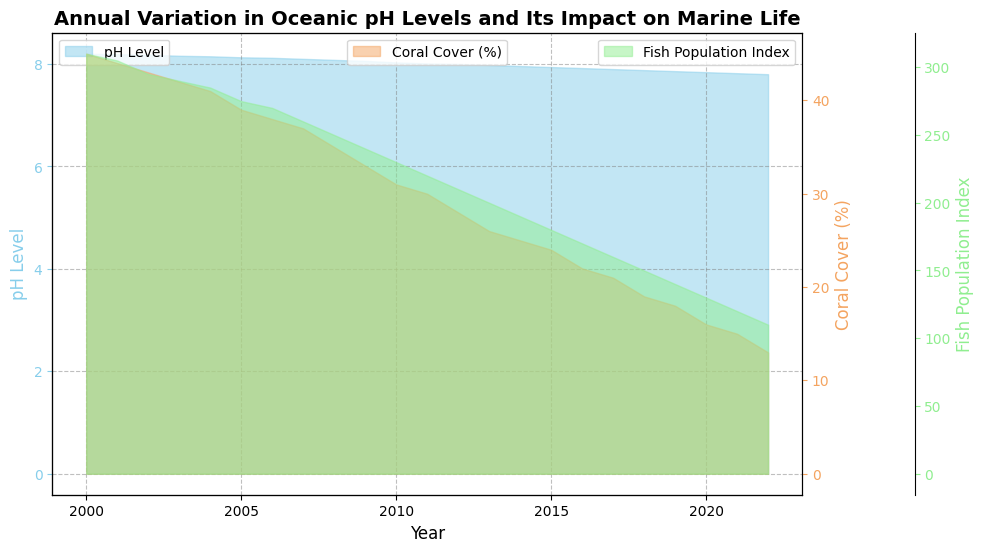What was the pH level in the year 2010? To find the pH level for the year 2010, look at the x-axis to locate the year 2010 and then look vertically to find the corresponding pH level plotted.
Answer: 8.03 How has the pH level generally trended from 2000 to 2022? Locate the pH levels across the years from 2000 to 2022 and observe the overall trend. The pH level shows a consistent decline over the years.
Answer: Declined What are the years when the Coral Cover (%) was at its highest and lowest? Check the Coral Cover axis and locate the highest and lowest points visually on the area chart, then find the corresponding years on the x-axis. The highest Coral Cover (%) was in 2000, and the lowest was in 2022.
Answer: 2000 and 2022 Compare the Fish Population Index between 2005 and 2015. Which year had a higher index? Look for the Fish Population Index values for 2005 and 2015. In 2005, it was 275, and in 2015, it was 180.
Answer: 2005 By how much did the Coral Cover (%) change from 2000 to 2022? Find the Coral Cover (%) in 2000 and 2022, which are 45 and 13, respectively. Subtract the latter from the former (45 - 13).
Answer: 32 How does the decrease in pH level seem to impact Coral Cover (%)? Observe the trend of pH level and Coral Cover (%). A decrease in pH level is associated with a decrease in Coral Cover (%).
Answer: Decreased pH level leads to decreased Coral Cover (%) What was the Fish Population Index in the year with the lowest Coral Cover (%)? Identify the year with the lowest Coral Cover (%), which is 2022, and then find the Fish Population Index for that year. It is 110 in 2022.
Answer: 110 How does the Fish Population Index compare between the years 2000 and 2022? Look at the Fish Population Index values for 2000 and 2022. In 2000, it was 310, and in 2022, it was 110. Compare the two values.
Answer: Declined by 200 Calculate the average pH level from 2000 to 2022. Sum up all the pH levels from 2000 to 2022 and divide by the number of data points (23). The sum is 180.49 and the average is 180.49/23.
Answer: 7.852 